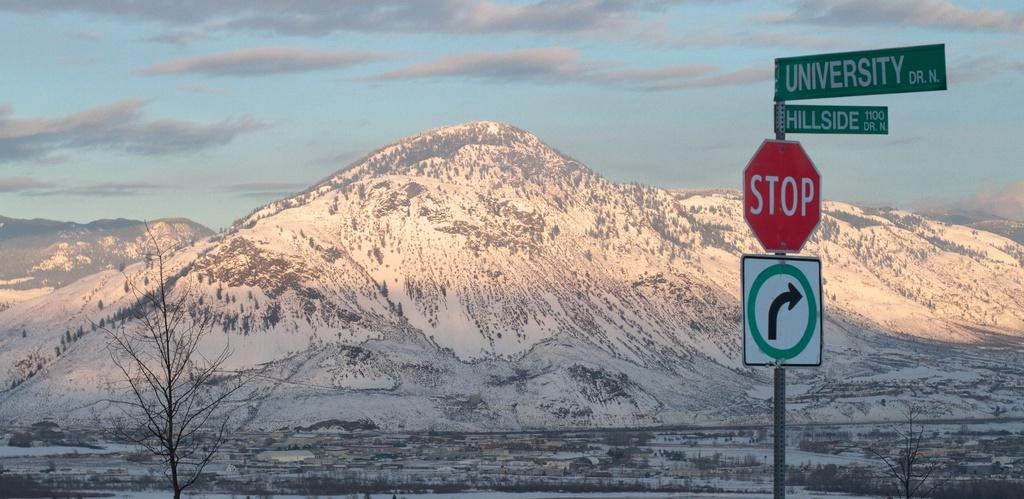Provide a one-sentence caption for the provided image. A stop sign is shown at the corner of University Dr. and Hillside Dr., with snow covered mountains in the background. 